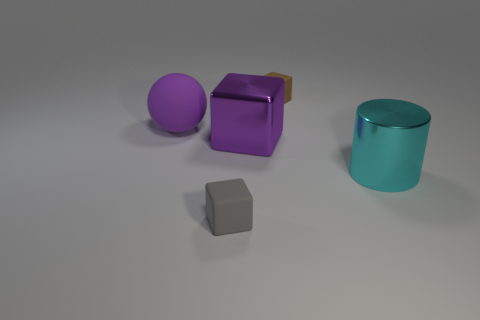Subtract all tiny matte cubes. How many cubes are left? 1 Subtract 1 blocks. How many blocks are left? 2 Subtract all brown cubes. How many cubes are left? 2 Subtract all cyan balls. Subtract all gray blocks. How many balls are left? 1 Subtract all brown blocks. How many brown spheres are left? 0 Subtract all large matte objects. Subtract all purple metal blocks. How many objects are left? 3 Add 3 gray blocks. How many gray blocks are left? 4 Add 3 large metal cubes. How many large metal cubes exist? 4 Add 4 cyan things. How many objects exist? 9 Subtract 1 purple blocks. How many objects are left? 4 